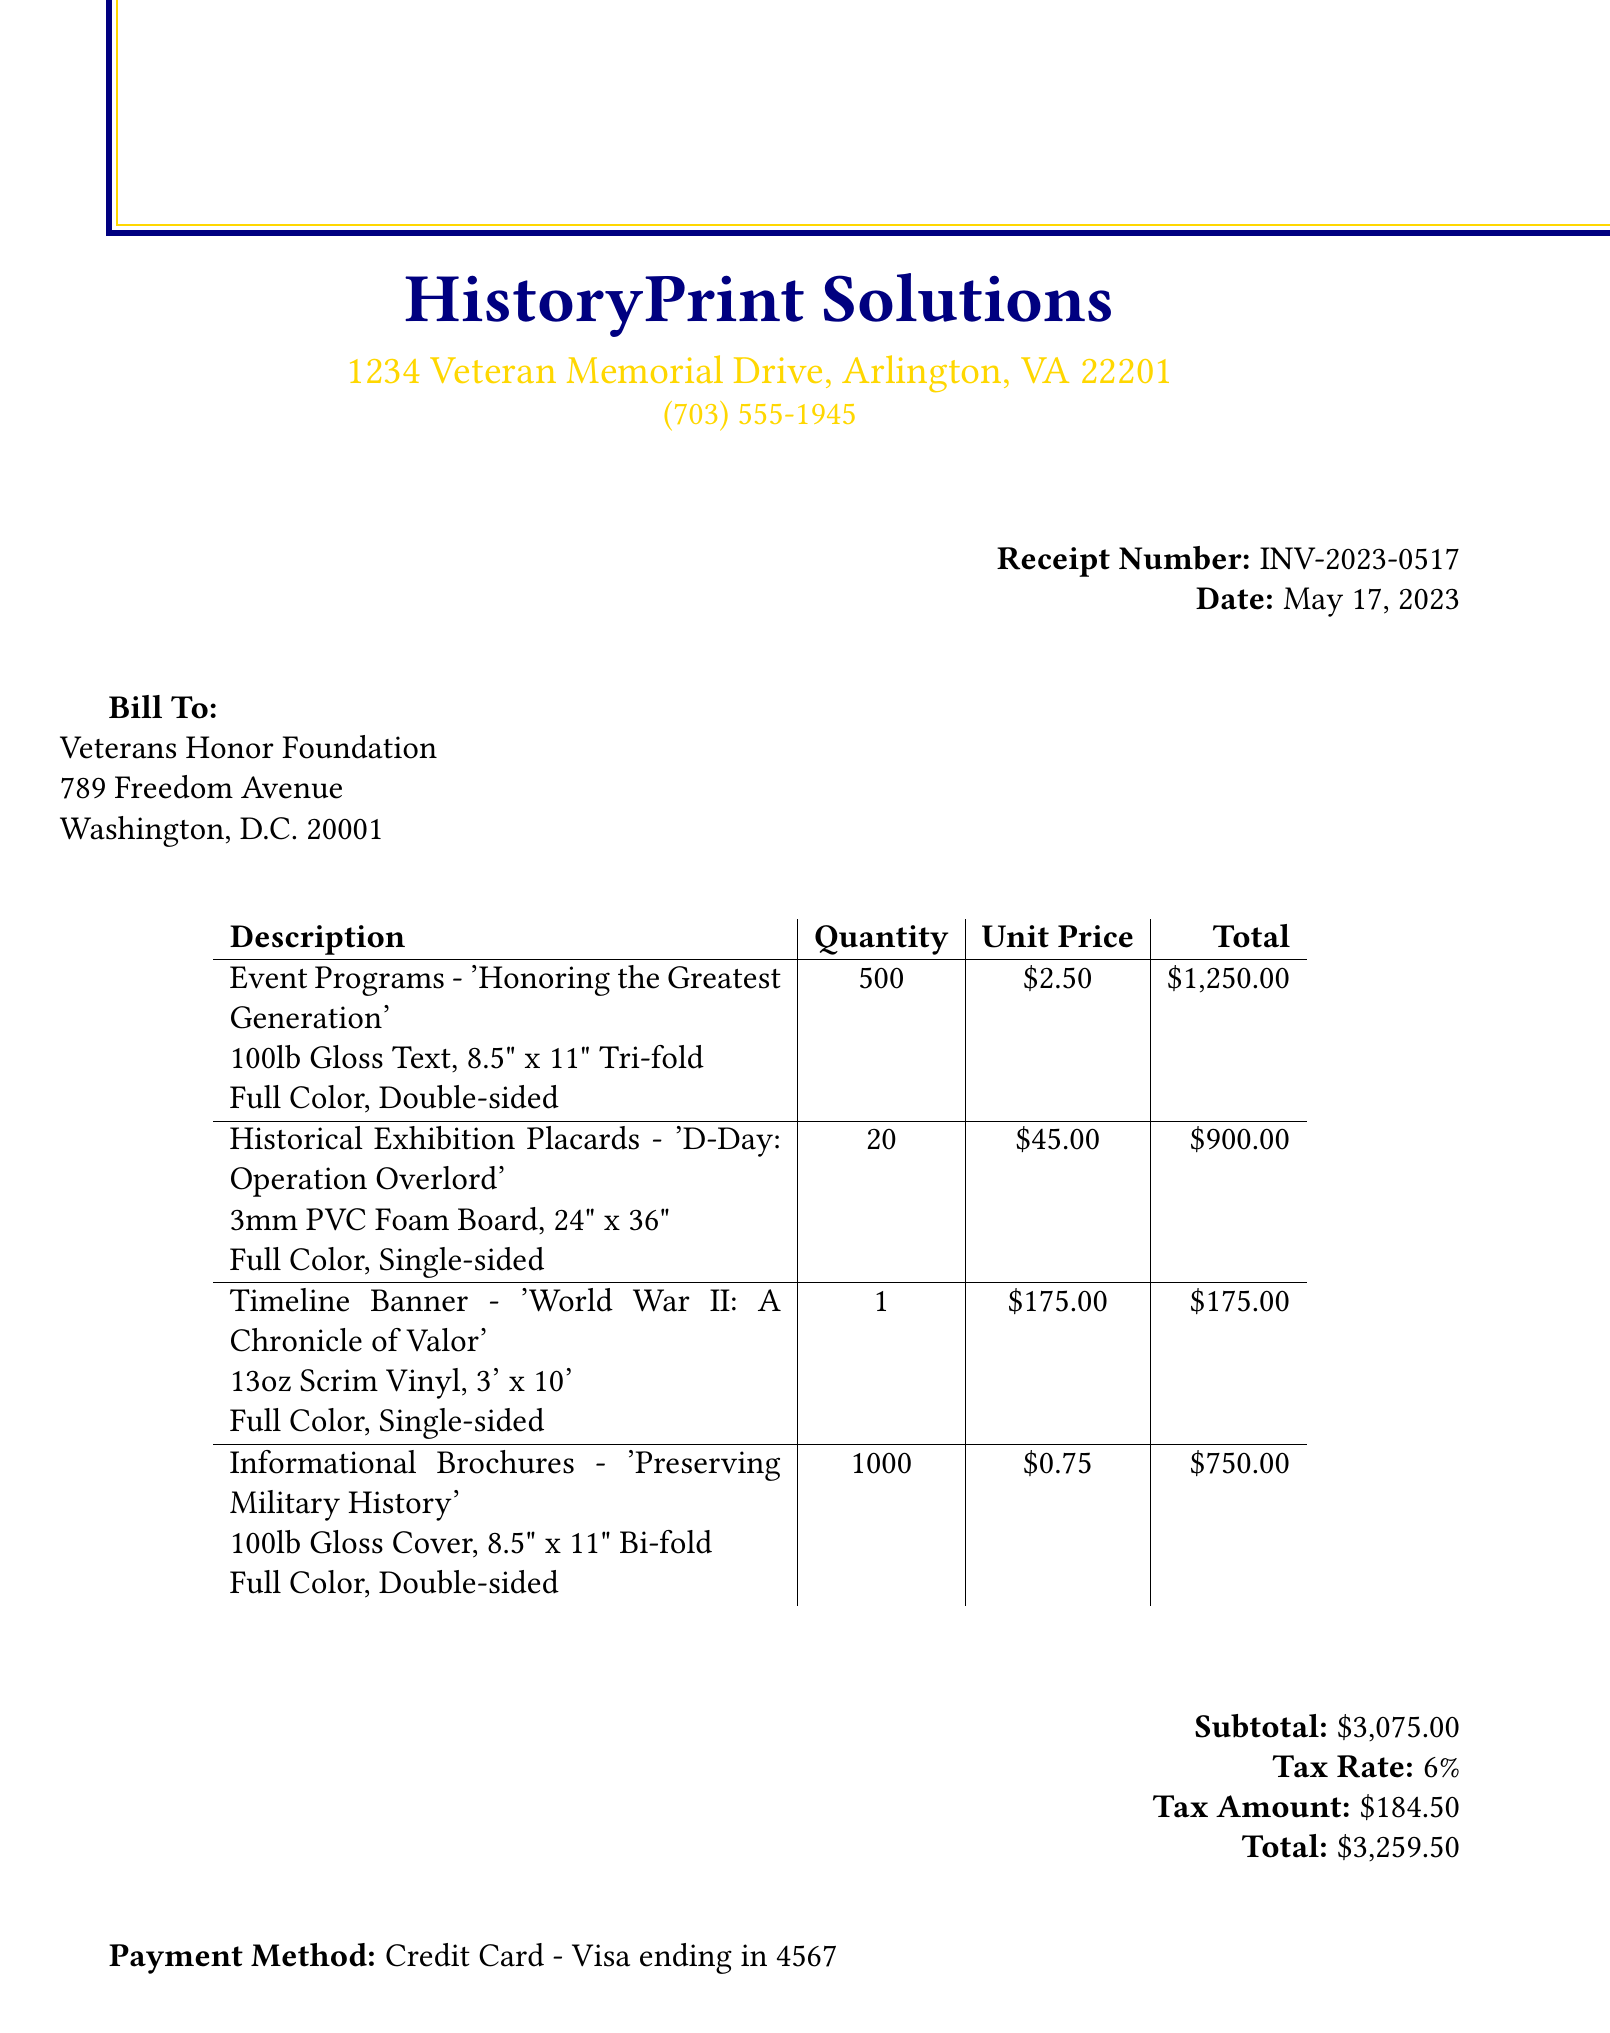What is the receipt number? The receipt number is specifically mentioned at the top of the document.
Answer: INV-2023-0517 Who is the vendor? The vendor's name is listed in the document.
Answer: HistoryPrint Solutions What is the quantity of event programs? The document states the quantity of event programs ordered.
Answer: 500 What is the total amount charged? The total amount is provided at the bottom of the receipt.
Answer: $3,259.50 What type of paper is used for the exhibition placards? The paper type for the exhibition placards is detailed in the item description.
Answer: 3mm PVC Foam Board How many informational brochures were ordered? The order quantity for the informational brochures is indicated in the items list.
Answer: 1000 What is the tax amount? The tax amount is specified in the financial summary of the document.
Answer: $184.50 When is the delivery due? The special instructions at the bottom provide the delivery deadline.
Answer: May 25, 2023 What payment method was used? The payment method is mentioned in the document.
Answer: Credit Card - Visa ending in 4567 